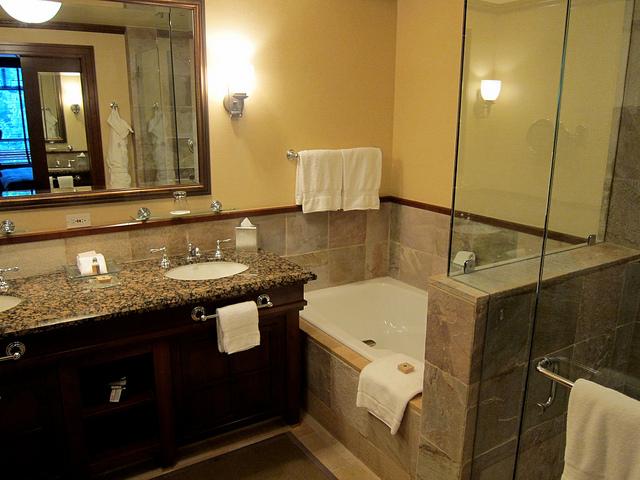Is this indoors?
Answer briefly. Yes. Are there towels on the floor?
Quick response, please. No. Is this a living room?
Concise answer only. No. Are those oak cabinets?
Answer briefly. No. What color is the towel on the tub?
Answer briefly. White. What is this room used for?
Quick response, please. Bathing. What type of lighting is illuminating this indoor space?
Quick response, please. Indoor lights. What kind of lighting was installed?
Write a very short answer. Soft. Is this bathroom finished?
Keep it brief. Yes. Which room is this?
Keep it brief. Bathroom. How many lights fixtures are there?
Answer briefly. 2. 